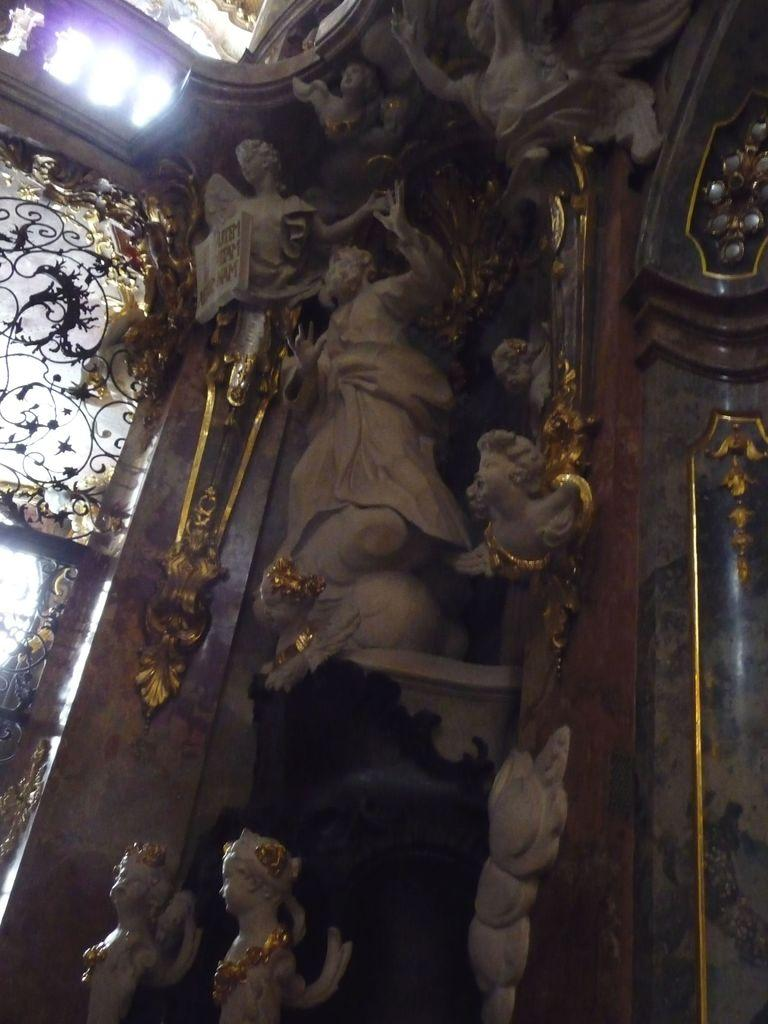What is depicted on the wall in the image? There are sculptures on the wall in the image. Can you describe the window in the image? There is a window on the left side of the image. What type of texture can be seen on the sculptures in the image? The provided facts do not mention the texture of the sculptures, so we cannot determine the texture from the image. Is your dad present in the image? There is no information about your dad in the image or the provided facts, so we cannot determine if he is present. 